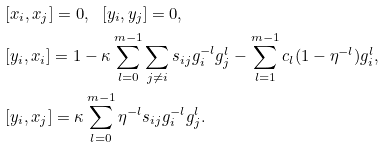<formula> <loc_0><loc_0><loc_500><loc_500>& [ x _ { i } , x _ { j } ] = 0 , \ \ [ y _ { i } , y _ { j } ] = 0 , \\ & [ y _ { i } , x _ { i } ] = 1 - { \kappa } \sum _ { l = 0 } ^ { m - 1 } \sum _ { j \neq i } s _ { i j } g _ { i } ^ { - l } g _ { j } ^ { l } - \sum _ { l = 1 } ^ { m - 1 } { c } _ { l } ( 1 - \eta ^ { - l } ) g _ { i } ^ { l } , \\ & [ y _ { i } , x _ { j } ] = { \kappa } \sum _ { l = 0 } ^ { m - 1 } \eta ^ { - l } s _ { i j } g _ { i } ^ { - l } g _ { j } ^ { l } .</formula> 